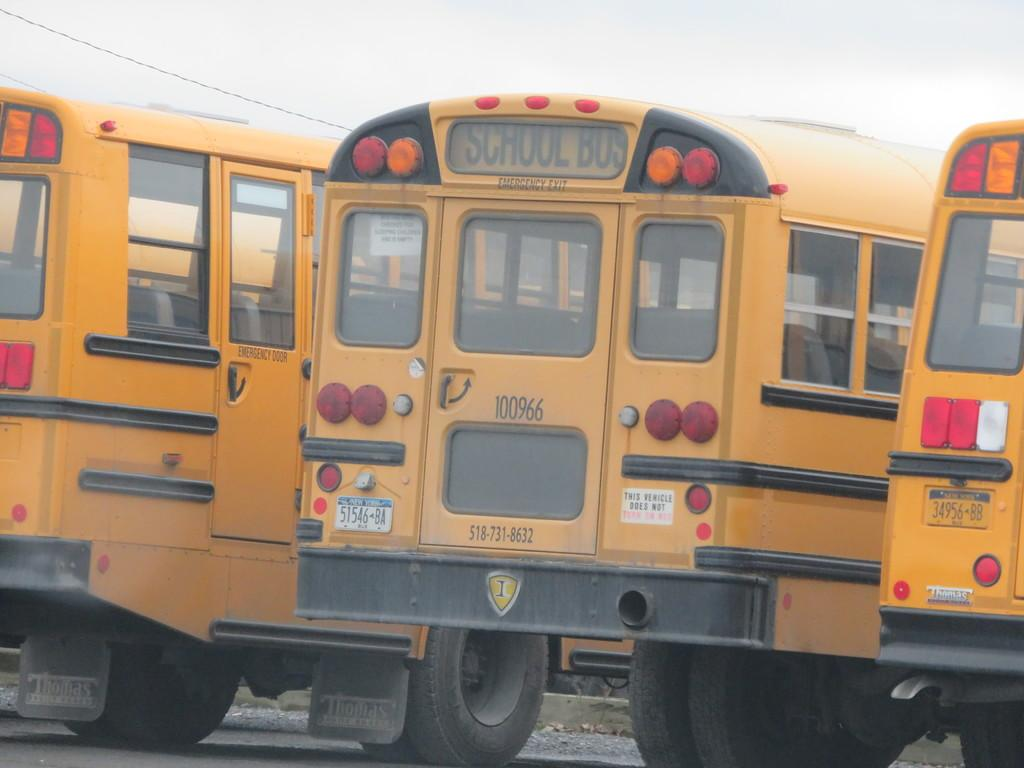What type of vehicles are present in the image? There are yellow buses in the image. Where are the buses located? The buses are on a surface in the image. What else can be seen in the image besides the buses? There is a wire visible in the image. What is visible in the background of the image? The sky is visible in the image. How many legs can be seen on the lumber in the image? There is no lumber present in the image, and therefore no legs can be seen. 